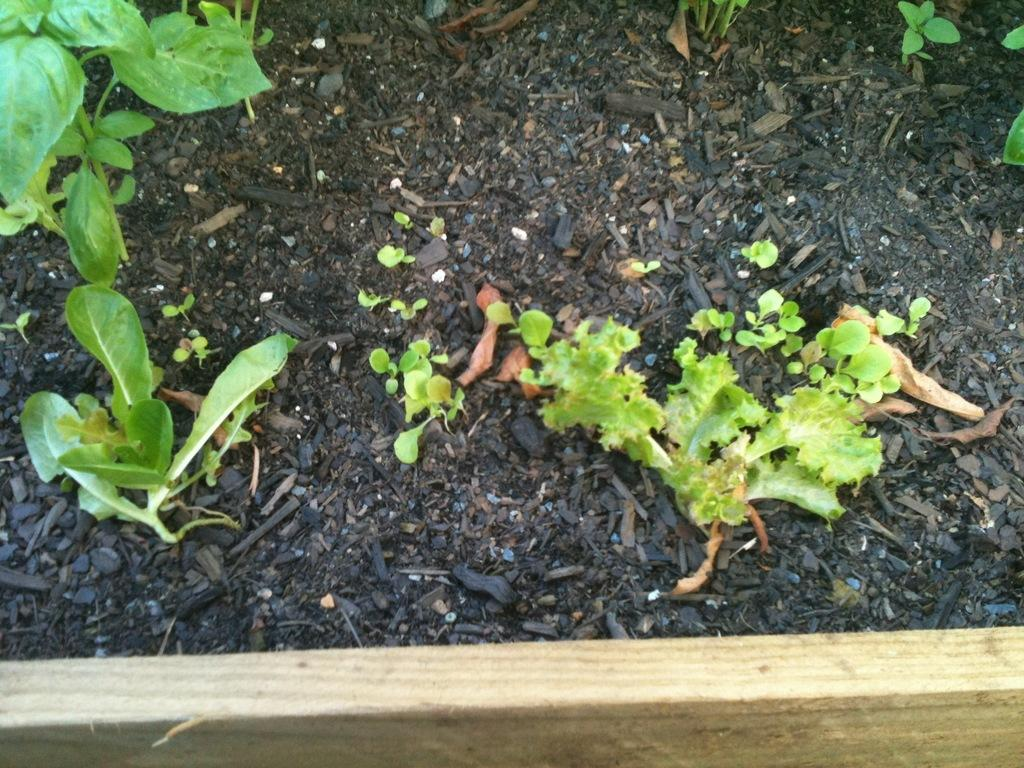What type of structure is present in the image? There is a wooden frame in the image. What can be seen behind the wooden frame? Soil is visible behind the wooden frame. What is growing in the soil? There are plants in the soil. What type of marble is used to decorate the hospital in the image? There is no hospital or marble present in the image; it features a wooden frame with soil and plants. How is the hook attached to the wooden frame in the image? There is no hook present in the image; it only features a wooden frame, soil, and plants. 